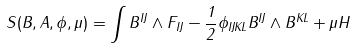Convert formula to latex. <formula><loc_0><loc_0><loc_500><loc_500>S ( B , A , \phi , \mu ) = \int B ^ { I J } \wedge F _ { I J } - \frac { 1 } { 2 } \phi _ { I J K L } B ^ { I J } \wedge B ^ { K L } + \mu H</formula> 